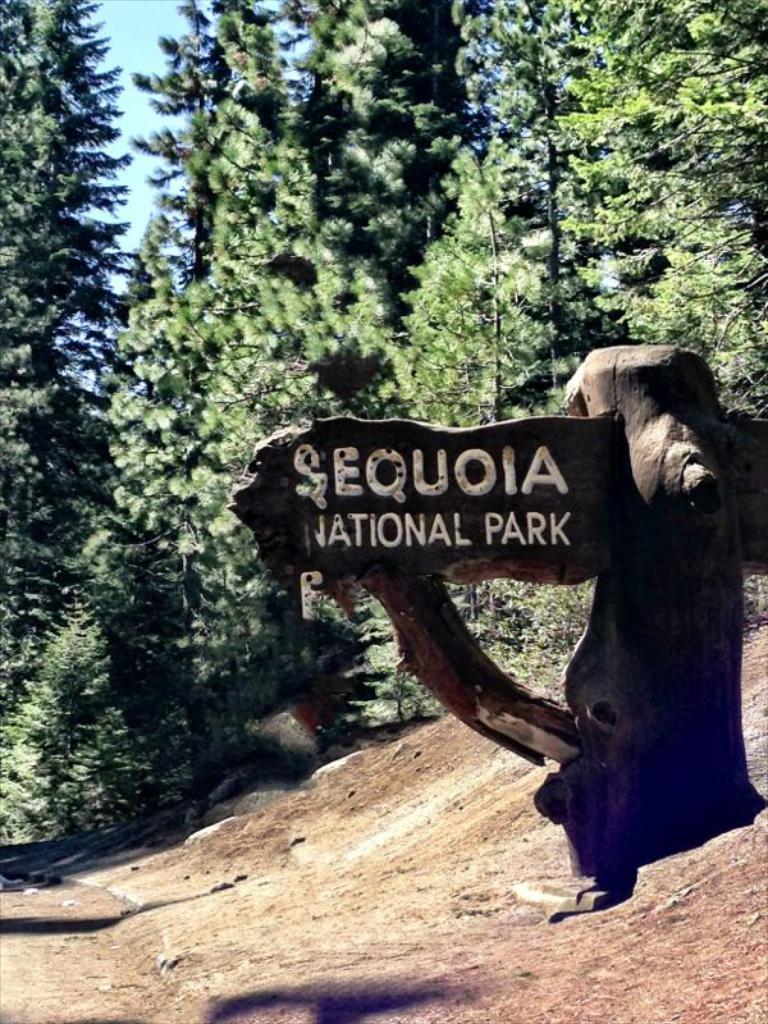In one or two sentences, can you explain what this image depicts? In the center of the image, we can see a name board and in the background, there are trees. At the bottom, there is a ground. 